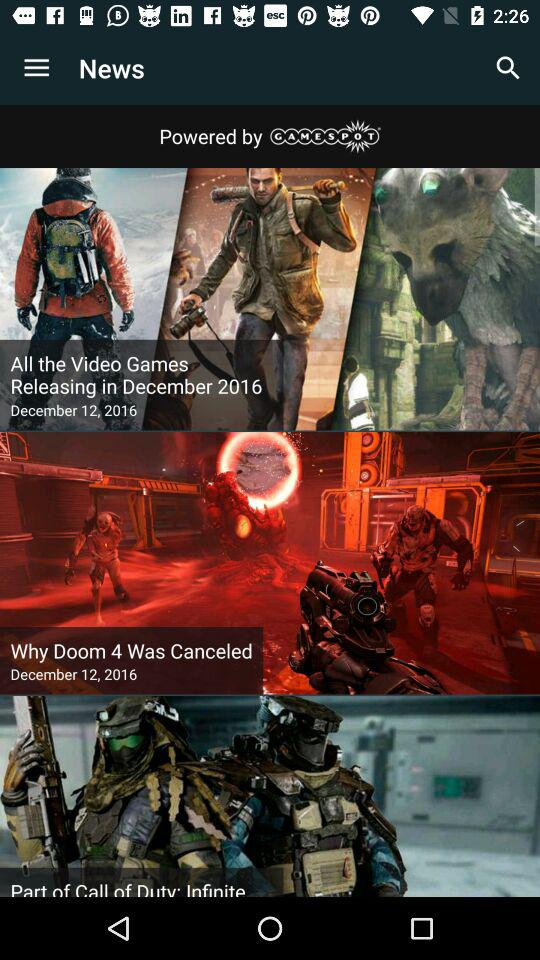When are the video games releasing? The video games are releasing in December 2016. 